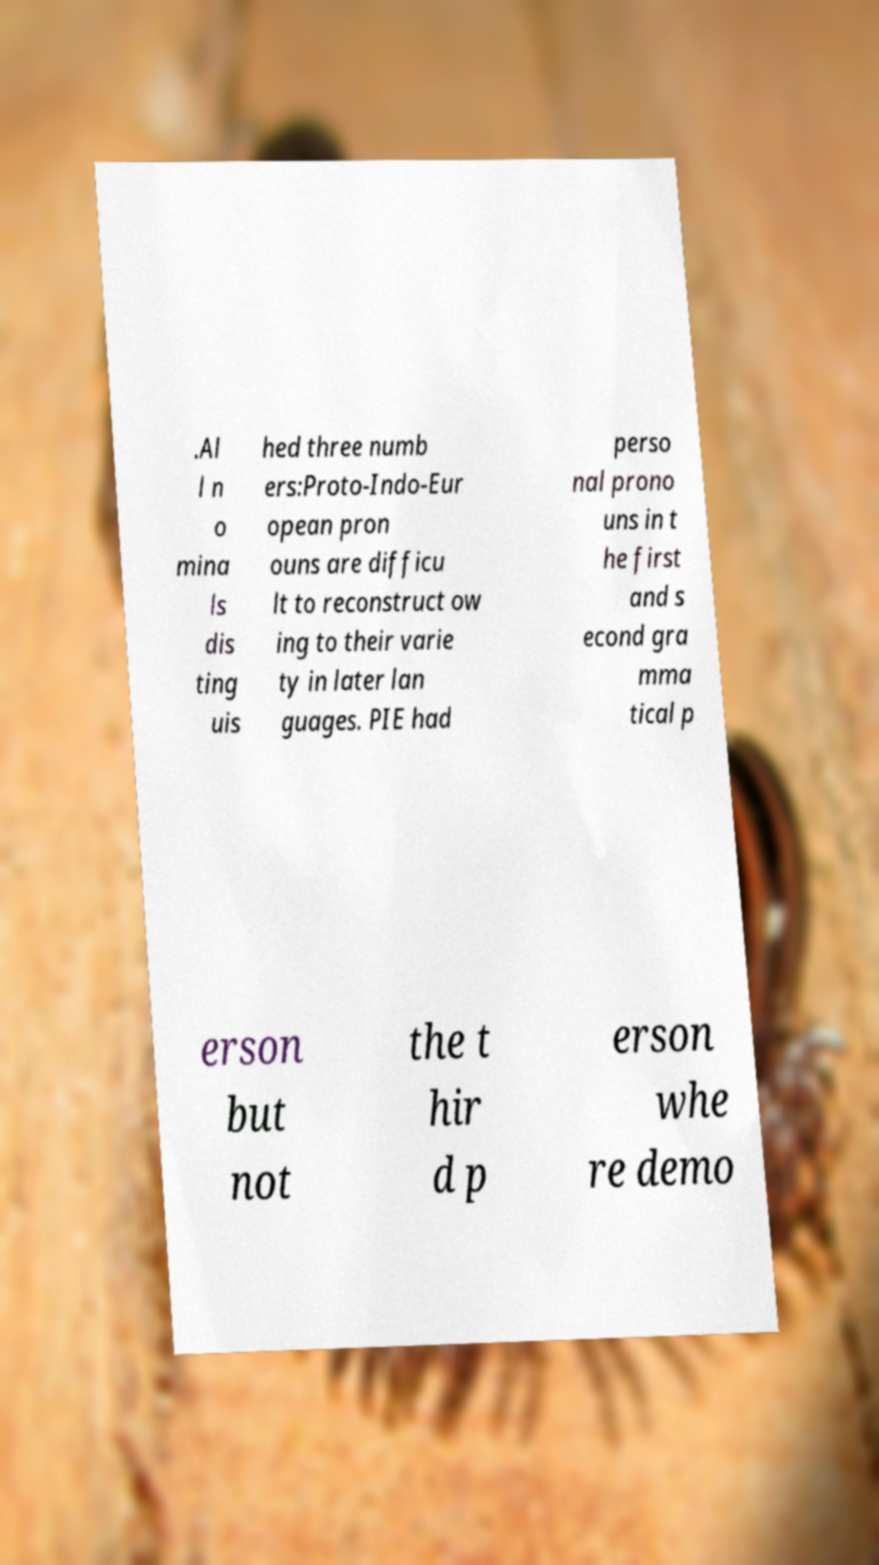Please read and relay the text visible in this image. What does it say? .Al l n o mina ls dis ting uis hed three numb ers:Proto-Indo-Eur opean pron ouns are difficu lt to reconstruct ow ing to their varie ty in later lan guages. PIE had perso nal prono uns in t he first and s econd gra mma tical p erson but not the t hir d p erson whe re demo 